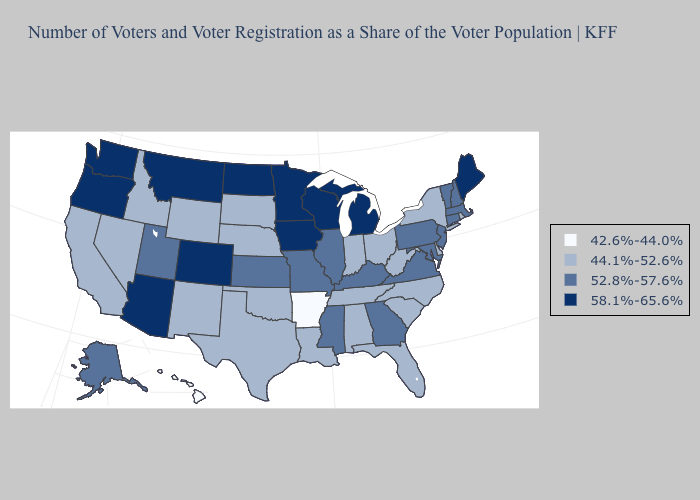What is the value of Pennsylvania?
Short answer required. 52.8%-57.6%. Does Rhode Island have the same value as New Mexico?
Be succinct. Yes. Does Colorado have a lower value than Nevada?
Answer briefly. No. Name the states that have a value in the range 52.8%-57.6%?
Answer briefly. Alaska, Connecticut, Georgia, Illinois, Kansas, Kentucky, Maryland, Massachusetts, Mississippi, Missouri, New Hampshire, New Jersey, Pennsylvania, Utah, Vermont, Virginia. Among the states that border Georgia , which have the lowest value?
Quick response, please. Alabama, Florida, North Carolina, South Carolina, Tennessee. Which states have the highest value in the USA?
Keep it brief. Arizona, Colorado, Iowa, Maine, Michigan, Minnesota, Montana, North Dakota, Oregon, Washington, Wisconsin. Name the states that have a value in the range 58.1%-65.6%?
Short answer required. Arizona, Colorado, Iowa, Maine, Michigan, Minnesota, Montana, North Dakota, Oregon, Washington, Wisconsin. What is the value of Connecticut?
Quick response, please. 52.8%-57.6%. Does Virginia have the highest value in the South?
Answer briefly. Yes. Among the states that border Missouri , does Arkansas have the highest value?
Concise answer only. No. What is the value of Wisconsin?
Give a very brief answer. 58.1%-65.6%. Which states have the highest value in the USA?
Concise answer only. Arizona, Colorado, Iowa, Maine, Michigan, Minnesota, Montana, North Dakota, Oregon, Washington, Wisconsin. Among the states that border Arkansas , does Texas have the lowest value?
Quick response, please. Yes. Does Vermont have a lower value than Virginia?
Keep it brief. No. Among the states that border Wyoming , does Montana have the lowest value?
Answer briefly. No. 